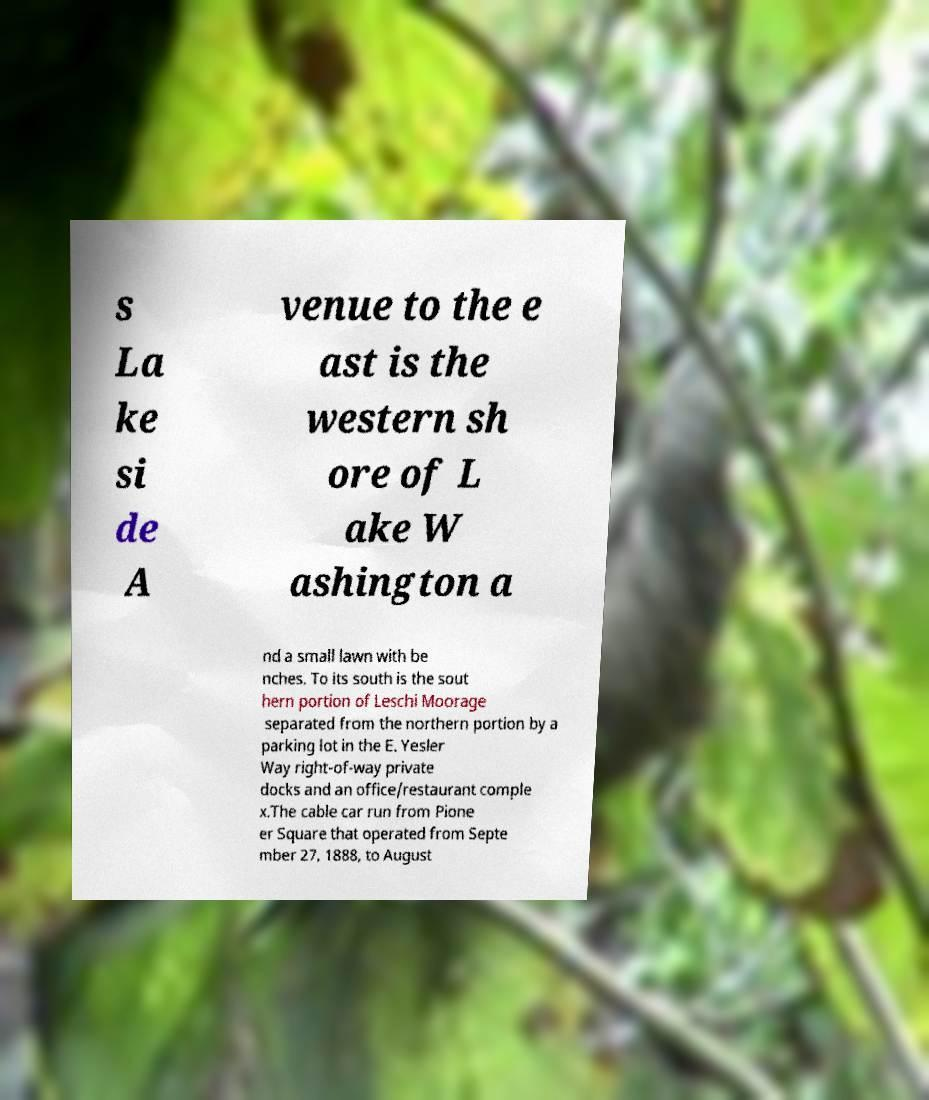There's text embedded in this image that I need extracted. Can you transcribe it verbatim? s La ke si de A venue to the e ast is the western sh ore of L ake W ashington a nd a small lawn with be nches. To its south is the sout hern portion of Leschi Moorage separated from the northern portion by a parking lot in the E. Yesler Way right-of-way private docks and an office/restaurant comple x.The cable car run from Pione er Square that operated from Septe mber 27, 1888, to August 